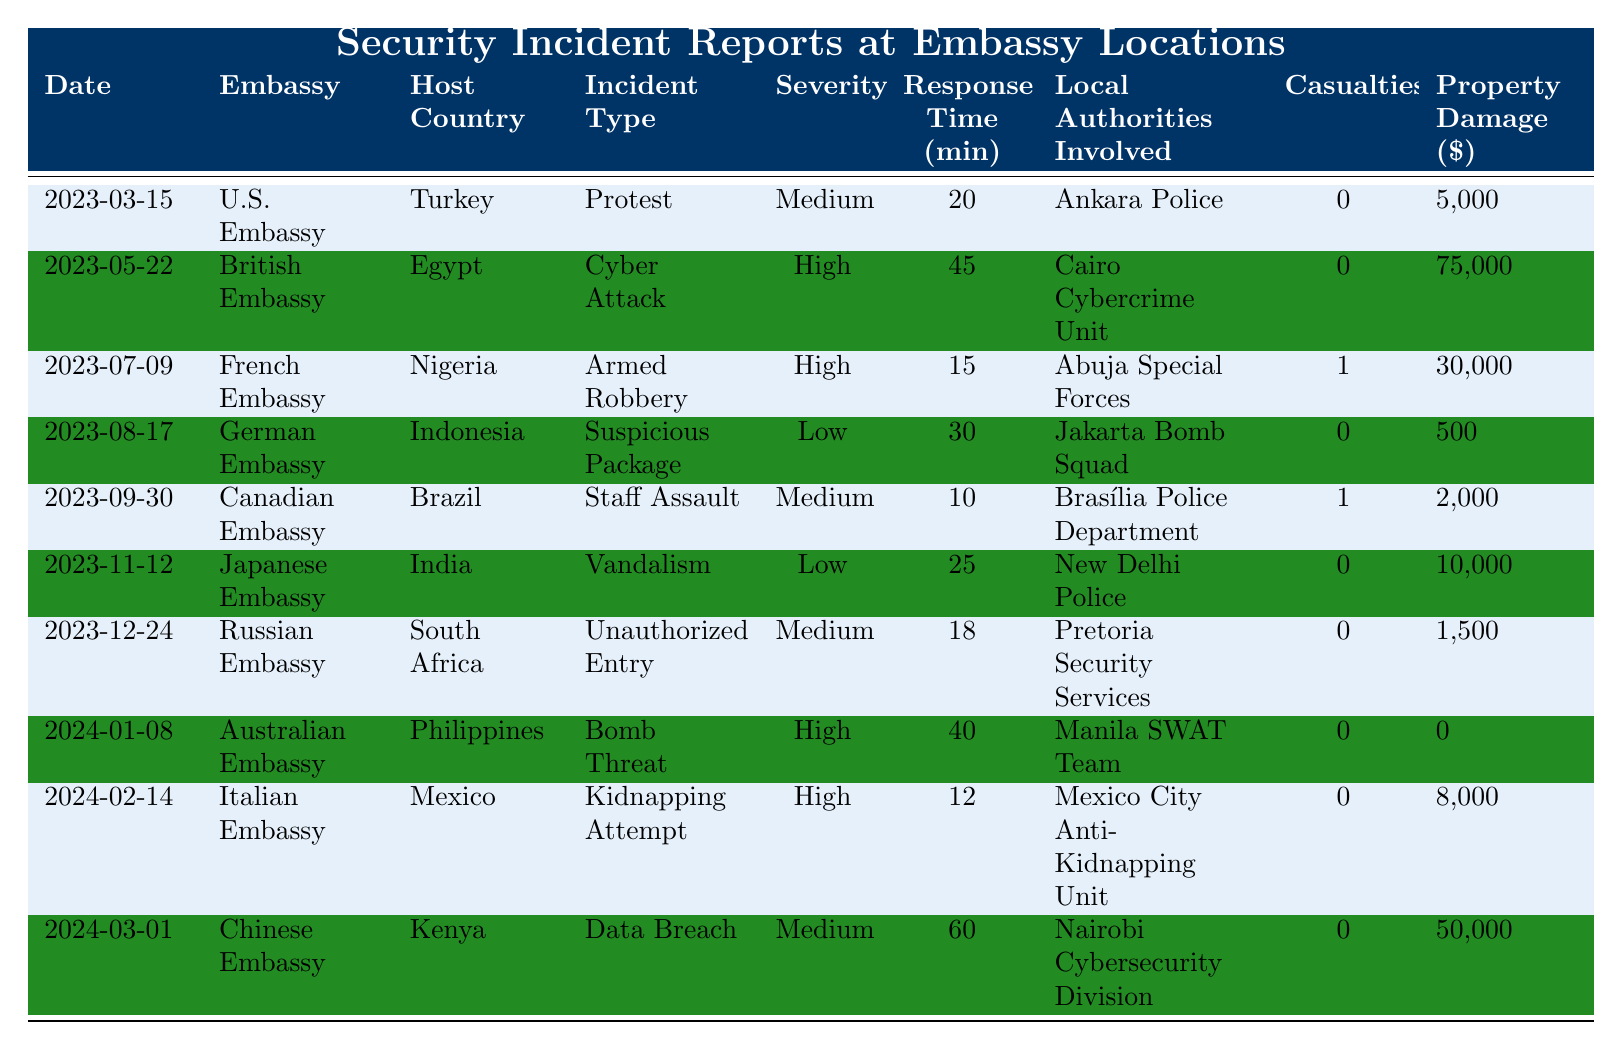What incident type occurred at the Japanese Embassy? The table shows that on November 12, 2023, the incident type at the Japanese Embassy was Vandalism.
Answer: Vandalism Which embassy reported the highest property damage? Comparing the property damages listed, the British Embassy had the highest damage of $75,000 due to a Cyber Attack.
Answer: British Embassy What was the average response time for all incidents listed? To find the average response time, sum the response times: (20 + 45 + 15 + 30 + 10 + 25 + 18 + 40 + 12 + 60) =  275. There are 10 incidents, so the average response time is 275/10 = 27.5 minutes.
Answer: 27.5 minutes Did any incidents result in casualties? Checking the table, the incidents that resulted in casualties are: Armed Robbery (1) and Staff Assault (1). Therefore, there were incidents with casualties.
Answer: Yes Which embassy had the lowest severity rating and what was the incident? The lowest severity rating was "Low," which corresponds to two incidents: Suspicious Package at the German Embassy and Vandalism at the Japanese Embassy.
Answer: German Embassy and Japanese Embassy How many incidents involved local authorities from Nigeria? In the table, only one incident involved Nigerian authorities, which was the Armed Robbery at the French Embassy.
Answer: 1 What is the total property damage cost for all reported incidents? To find the total property damage, sum all the values: 5000 + 75000 + 30000 + 500 + 2000 + 10000 + 1500 + 0 + 8000 + 50000 = 250000.
Answer: $250,000 Is there any incident without local authorities involvement? Yes, looking through the table, the incident on January 8, 2024, at the Australian Embassy (Bomb Threat) involved local authorities but had no casualties or property damage.
Answer: Yes Which embassy reported a Kidnapping Attempt, and what was the severity? According to the table, the Italian Embassy reported a Kidnapping Attempt on February 14, 2024, with a severity rating of High.
Answer: Italian Embassy, High How many incidents involved local authorities from South Africa? The table shows there was one incident involving South African authorities, which was the Unauthorized Entry at the Russian Embassy.
Answer: 1 